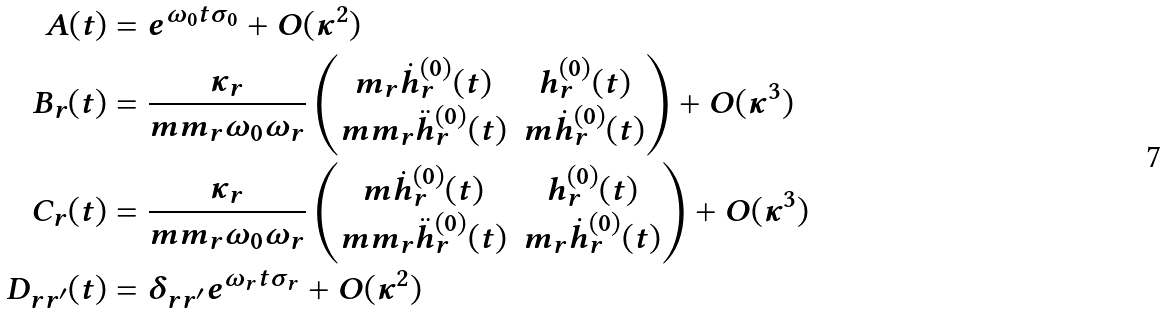Convert formula to latex. <formula><loc_0><loc_0><loc_500><loc_500>A ( t ) & = e ^ { \omega _ { 0 } t \sigma _ { 0 } } + O ( \kappa ^ { 2 } ) \\ B _ { r } ( t ) & = \frac { \kappa _ { r } } { m m _ { r } \omega _ { 0 } \omega _ { r } } \begin{pmatrix} m _ { r } \dot { h } _ { r } ^ { ( 0 ) } ( t ) & h _ { r } ^ { ( 0 ) } ( t ) \\ m m _ { r } \ddot { h } _ { r } ^ { ( 0 ) } ( t ) & m \dot { h } _ { r } ^ { ( 0 ) } ( t ) \end{pmatrix} + O ( \kappa ^ { 3 } ) \\ C _ { r } ( t ) & = \frac { \kappa _ { r } } { m m _ { r } \omega _ { 0 } \omega _ { r } } \begin{pmatrix} m \dot { h } _ { r } ^ { ( 0 ) } ( t ) & h _ { r } ^ { ( 0 ) } ( t ) \\ m m _ { r } \ddot { h } _ { r } ^ { ( 0 ) } ( t ) & m _ { r } \dot { h } _ { r } ^ { ( 0 ) } ( t ) \end{pmatrix} + O ( \kappa ^ { 3 } ) \\ D _ { r r ^ { \prime } } ( t ) & = \delta _ { r r ^ { \prime } } e ^ { \omega _ { r } t \sigma _ { r } } + O ( \kappa ^ { 2 } )</formula> 